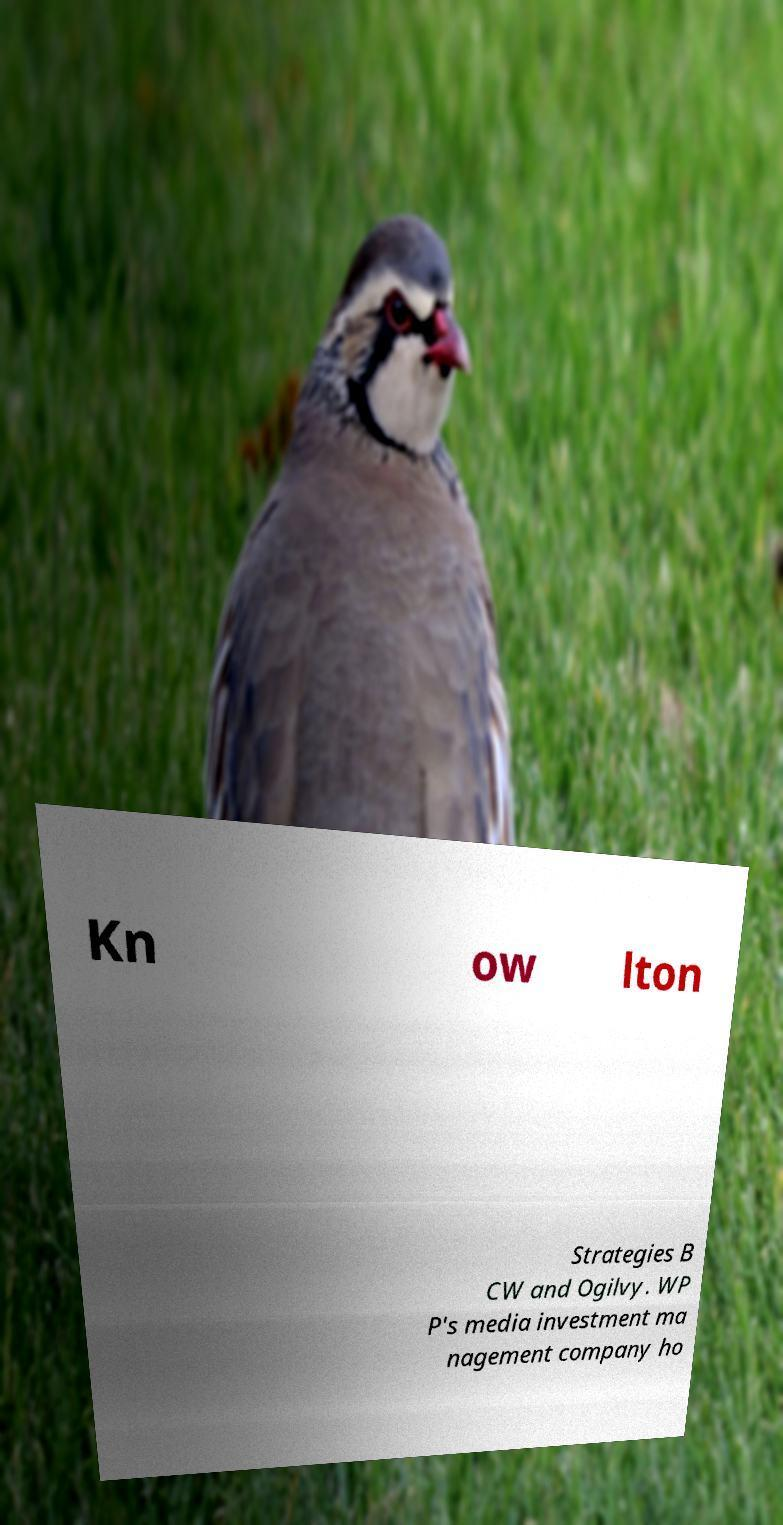Can you read and provide the text displayed in the image?This photo seems to have some interesting text. Can you extract and type it out for me? Kn ow lton Strategies B CW and Ogilvy. WP P's media investment ma nagement company ho 